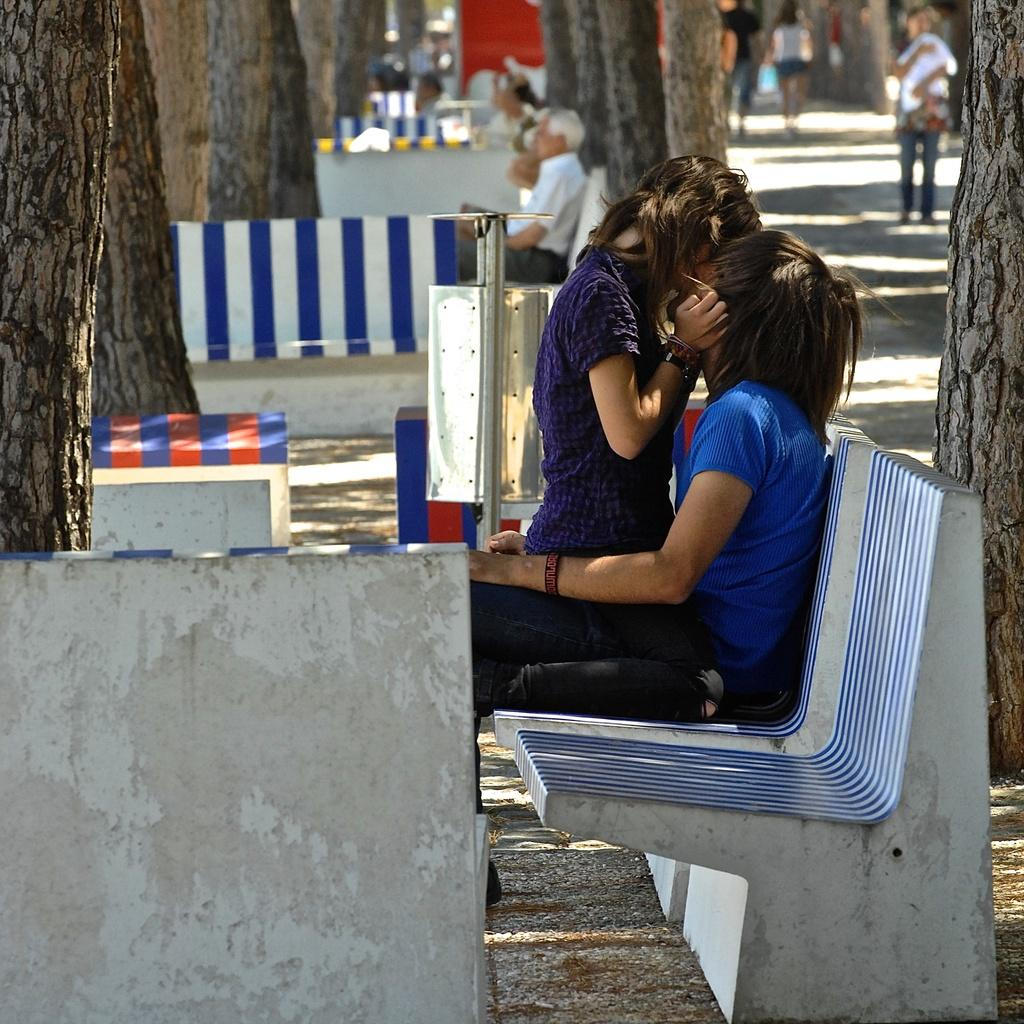Who is present in the image? There is a boy and a girl in the image. What are the boy and girl doing in the image? The boy and girl are kissing each other. Where are they sitting in the image? They are sitting on a bench. What can be seen in the background of the image? There are trees and people in the background of the image. What type of business is being conducted in the image? There is no indication of any business being conducted in the image; it features a boy and a girl kissing on a bench. Can you tell me how many zoo animals are visible in the image? There are no zoo animals present in the image. 